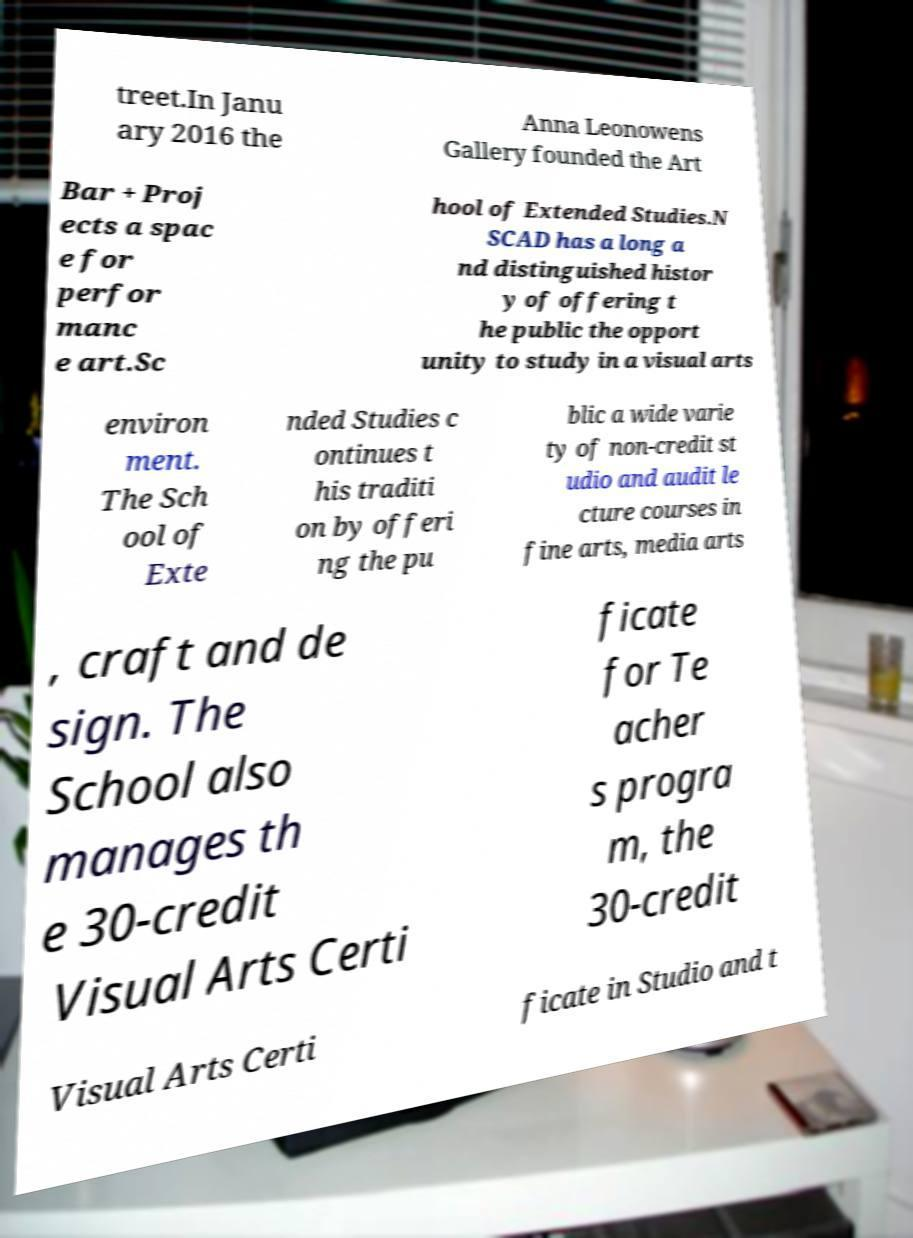For documentation purposes, I need the text within this image transcribed. Could you provide that? treet.In Janu ary 2016 the Anna Leonowens Gallery founded the Art Bar + Proj ects a spac e for perfor manc e art.Sc hool of Extended Studies.N SCAD has a long a nd distinguished histor y of offering t he public the opport unity to study in a visual arts environ ment. The Sch ool of Exte nded Studies c ontinues t his traditi on by offeri ng the pu blic a wide varie ty of non-credit st udio and audit le cture courses in fine arts, media arts , craft and de sign. The School also manages th e 30-credit Visual Arts Certi ficate for Te acher s progra m, the 30-credit Visual Arts Certi ficate in Studio and t 